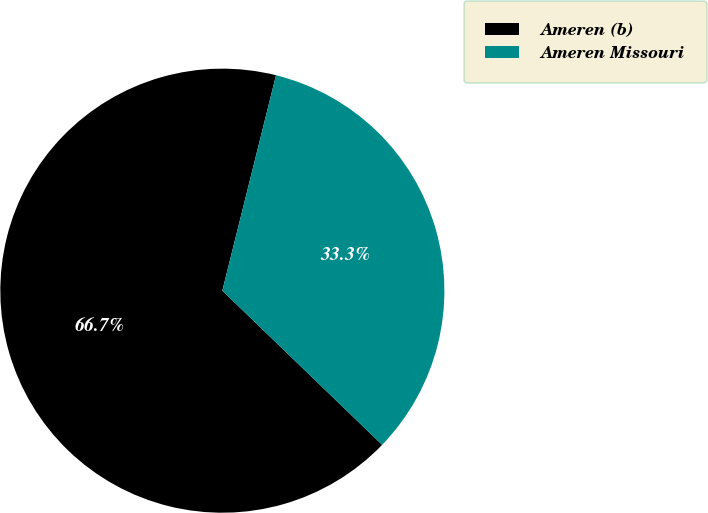<chart> <loc_0><loc_0><loc_500><loc_500><pie_chart><fcel>Ameren (b)<fcel>Ameren Missouri<nl><fcel>66.67%<fcel>33.33%<nl></chart> 